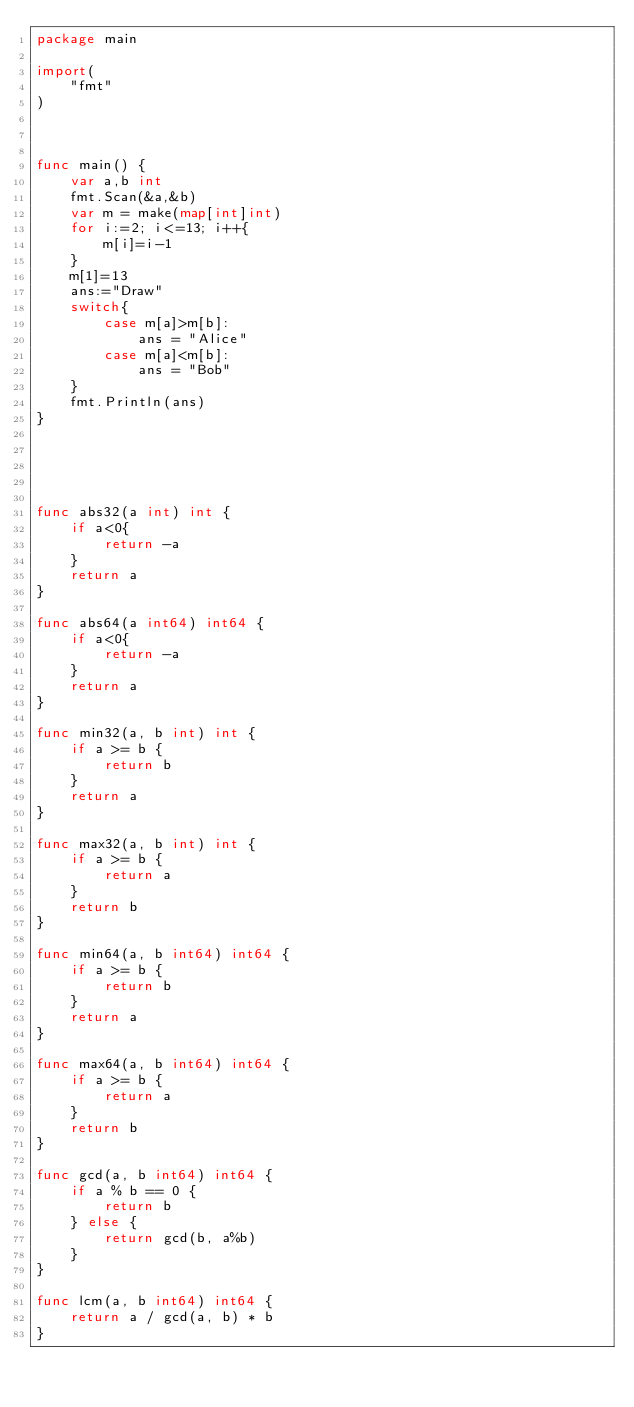Convert code to text. <code><loc_0><loc_0><loc_500><loc_500><_Go_>package main

import(
    "fmt"
)



func main() {
    var a,b int
    fmt.Scan(&a,&b)
    var m = make(map[int]int)
    for i:=2; i<=13; i++{
        m[i]=i-1
    }
    m[1]=13
    ans:="Draw"
    switch{
        case m[a]>m[b]:
            ans = "Alice"
        case m[a]<m[b]:
            ans = "Bob"
    }
    fmt.Println(ans)
}





func abs32(a int) int {
    if a<0{
        return -a
    }
    return a
}

func abs64(a int64) int64 {
    if a<0{
        return -a
    }
    return a
}

func min32(a, b int) int {
    if a >= b {
        return b
    }
    return a
}

func max32(a, b int) int {
    if a >= b {
        return a
    }
    return b
}

func min64(a, b int64) int64 {
    if a >= b {
        return b
    }
    return a
}

func max64(a, b int64) int64 {
    if a >= b {
        return a
    }
    return b
}

func gcd(a, b int64) int64 {
    if a % b == 0 {
        return b
    } else {
        return gcd(b, a%b)
    }
}

func lcm(a, b int64) int64 {
    return a / gcd(a, b) * b
}
</code> 